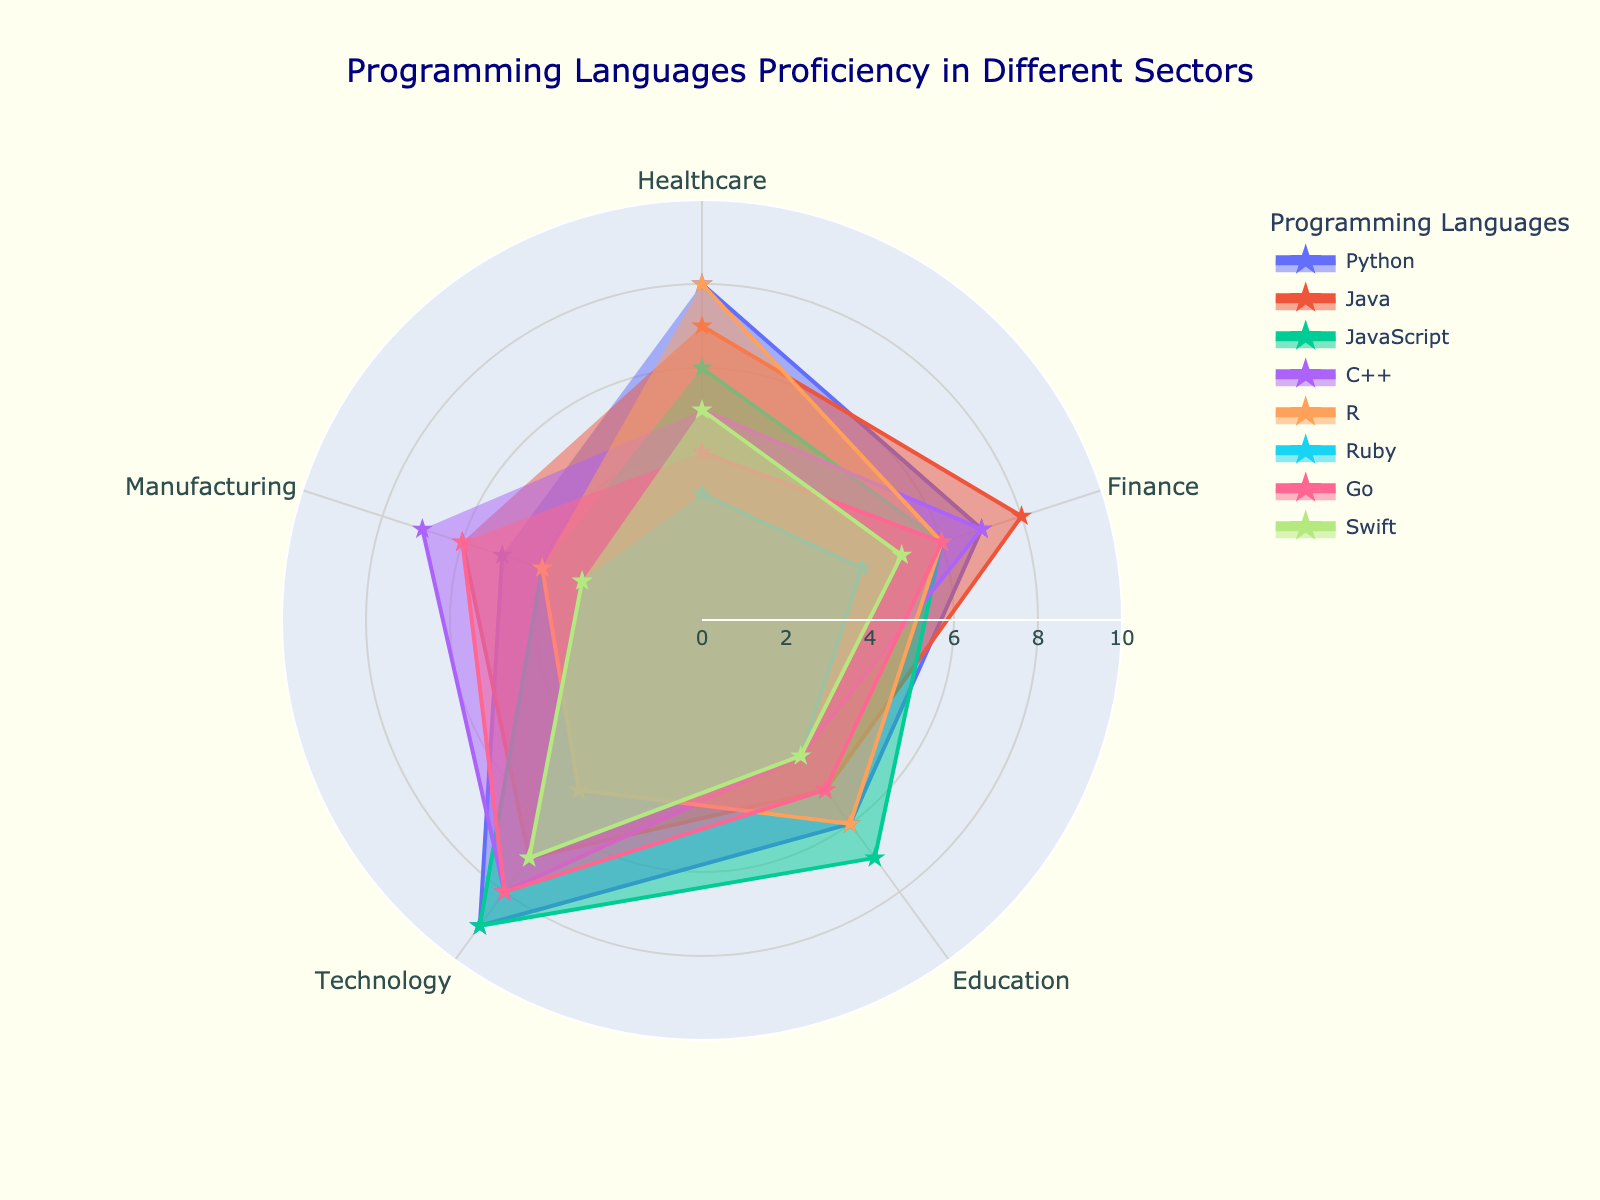what is the title of the radar chart? The title is visibly located at the top center of the radar chart, indicating the main focus of the data presented.
Answer: Programming Languages Proficiency in Different Sectors which programming language has the highest proficiency in the healthcare sector? By looking at the points in the healthcare sector and identifying the highest value, we observe that Python has the highest value at 8.
Answer: Python among Python, Java, and R, which programming language sees the highest usage frequency across all sectors? Summing up the values across all sectors for Python (8+7+6+9+5=35), Java (7+8+5+7+6=33), and R (8+6+6+5+4=29), we find that Python has the highest total frequency.
Answer: Python is JavaScript more frequently used in the technology sector compared to the manufacturing sector? Comparing the values for JavaScript in the technology sector (9) and manufacturing sector (4), it is evident that JavaScript is indeed more frequently used in the technology sector.
Answer: Yes which sector has the lowest proficiency for Swift? By examining the values for Swift across sectors (5 in Healthcare, 5 in Finance, 4 in Education, 7 in Technology, and 3 in Manufacturing), the lowest value is clearly in Manufacturing.
Answer: Manufacturing considering all sectors, which programming language shows the most even distribution of proficiency? Examining the radar chart, the lines for each programming language and looking for the most evenly spread points around the center, we find that JavaScript has a relatively even distribution (6, 6, 7, 9, 4).
Answer: JavaScript what is the average proficiency of Ruby across all sectors? Adding the proficiencies of Ruby in all sectors (3+4+4+7+3=21) and dividing by the number of sectors (5), we get the average: 21/5 = 4.2.
Answer: 4.2 how many programming languages have a proficiency score of 7 or higher in at least three sectors? By examining each programming language for scores of 7 or higher across sectors, Python (4 sectors), Java (3 sectors), and C++ (3 sectors) meet the criteria.
Answer: 3 between Go and C++, which programming language shows greater proficiency in the education sector? Observing the values for the education sector, Go has a proficiency of 5 whereas C++ has 4. Therefore, Go shows greater proficiency in the education sector.
Answer: Go which programming language has the most sectors with a proficiency score of exactly 5? By counting the score of 5 for each programming language across all sectors, we find that Swift has three sectors with a proficiency score of 5.
Answer: Swift 